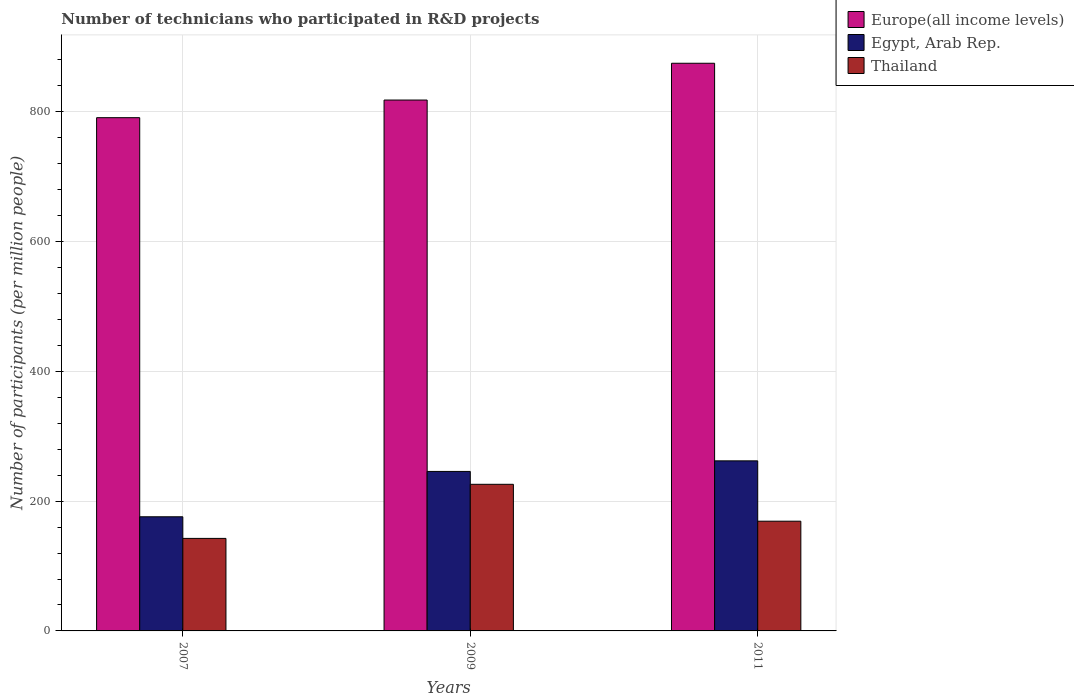Are the number of bars per tick equal to the number of legend labels?
Offer a terse response. Yes. Are the number of bars on each tick of the X-axis equal?
Your answer should be compact. Yes. What is the label of the 3rd group of bars from the left?
Give a very brief answer. 2011. What is the number of technicians who participated in R&D projects in Egypt, Arab Rep. in 2007?
Offer a very short reply. 175.89. Across all years, what is the maximum number of technicians who participated in R&D projects in Thailand?
Ensure brevity in your answer.  225.94. Across all years, what is the minimum number of technicians who participated in R&D projects in Europe(all income levels)?
Ensure brevity in your answer.  790.9. What is the total number of technicians who participated in R&D projects in Egypt, Arab Rep. in the graph?
Make the answer very short. 683.72. What is the difference between the number of technicians who participated in R&D projects in Europe(all income levels) in 2009 and that in 2011?
Provide a short and direct response. -56.67. What is the difference between the number of technicians who participated in R&D projects in Thailand in 2011 and the number of technicians who participated in R&D projects in Egypt, Arab Rep. in 2007?
Keep it short and to the point. -6.79. What is the average number of technicians who participated in R&D projects in Europe(all income levels) per year?
Offer a very short reply. 827.92. In the year 2007, what is the difference between the number of technicians who participated in R&D projects in Europe(all income levels) and number of technicians who participated in R&D projects in Egypt, Arab Rep.?
Give a very brief answer. 615.01. In how many years, is the number of technicians who participated in R&D projects in Egypt, Arab Rep. greater than 720?
Provide a succinct answer. 0. What is the ratio of the number of technicians who participated in R&D projects in Egypt, Arab Rep. in 2009 to that in 2011?
Provide a succinct answer. 0.94. Is the number of technicians who participated in R&D projects in Thailand in 2009 less than that in 2011?
Provide a short and direct response. No. What is the difference between the highest and the second highest number of technicians who participated in R&D projects in Egypt, Arab Rep.?
Your response must be concise. 16.3. What is the difference between the highest and the lowest number of technicians who participated in R&D projects in Egypt, Arab Rep.?
Provide a succinct answer. 86.18. What does the 2nd bar from the left in 2007 represents?
Your answer should be compact. Egypt, Arab Rep. What does the 1st bar from the right in 2009 represents?
Ensure brevity in your answer.  Thailand. Is it the case that in every year, the sum of the number of technicians who participated in R&D projects in Thailand and number of technicians who participated in R&D projects in Egypt, Arab Rep. is greater than the number of technicians who participated in R&D projects in Europe(all income levels)?
Ensure brevity in your answer.  No. How many bars are there?
Your response must be concise. 9. How many years are there in the graph?
Make the answer very short. 3. Are the values on the major ticks of Y-axis written in scientific E-notation?
Provide a short and direct response. No. Does the graph contain grids?
Provide a succinct answer. Yes. How many legend labels are there?
Make the answer very short. 3. What is the title of the graph?
Provide a succinct answer. Number of technicians who participated in R&D projects. Does "Gambia, The" appear as one of the legend labels in the graph?
Your answer should be compact. No. What is the label or title of the X-axis?
Your answer should be very brief. Years. What is the label or title of the Y-axis?
Your response must be concise. Number of participants (per million people). What is the Number of participants (per million people) of Europe(all income levels) in 2007?
Offer a very short reply. 790.9. What is the Number of participants (per million people) in Egypt, Arab Rep. in 2007?
Provide a short and direct response. 175.89. What is the Number of participants (per million people) of Thailand in 2007?
Provide a succinct answer. 142.58. What is the Number of participants (per million people) of Europe(all income levels) in 2009?
Provide a short and direct response. 818.09. What is the Number of participants (per million people) of Egypt, Arab Rep. in 2009?
Your answer should be compact. 245.77. What is the Number of participants (per million people) of Thailand in 2009?
Keep it short and to the point. 225.94. What is the Number of participants (per million people) of Europe(all income levels) in 2011?
Offer a terse response. 874.77. What is the Number of participants (per million people) in Egypt, Arab Rep. in 2011?
Give a very brief answer. 262.07. What is the Number of participants (per million people) of Thailand in 2011?
Your answer should be very brief. 169.1. Across all years, what is the maximum Number of participants (per million people) of Europe(all income levels)?
Provide a short and direct response. 874.77. Across all years, what is the maximum Number of participants (per million people) of Egypt, Arab Rep.?
Give a very brief answer. 262.07. Across all years, what is the maximum Number of participants (per million people) in Thailand?
Offer a terse response. 225.94. Across all years, what is the minimum Number of participants (per million people) of Europe(all income levels)?
Provide a succinct answer. 790.9. Across all years, what is the minimum Number of participants (per million people) of Egypt, Arab Rep.?
Provide a short and direct response. 175.89. Across all years, what is the minimum Number of participants (per million people) of Thailand?
Provide a short and direct response. 142.58. What is the total Number of participants (per million people) of Europe(all income levels) in the graph?
Your answer should be compact. 2483.76. What is the total Number of participants (per million people) in Egypt, Arab Rep. in the graph?
Keep it short and to the point. 683.72. What is the total Number of participants (per million people) of Thailand in the graph?
Provide a succinct answer. 537.62. What is the difference between the Number of participants (per million people) of Europe(all income levels) in 2007 and that in 2009?
Give a very brief answer. -27.19. What is the difference between the Number of participants (per million people) in Egypt, Arab Rep. in 2007 and that in 2009?
Keep it short and to the point. -69.88. What is the difference between the Number of participants (per million people) in Thailand in 2007 and that in 2009?
Keep it short and to the point. -83.36. What is the difference between the Number of participants (per million people) in Europe(all income levels) in 2007 and that in 2011?
Your response must be concise. -83.87. What is the difference between the Number of participants (per million people) in Egypt, Arab Rep. in 2007 and that in 2011?
Provide a succinct answer. -86.18. What is the difference between the Number of participants (per million people) in Thailand in 2007 and that in 2011?
Provide a short and direct response. -26.51. What is the difference between the Number of participants (per million people) of Europe(all income levels) in 2009 and that in 2011?
Provide a succinct answer. -56.67. What is the difference between the Number of participants (per million people) of Egypt, Arab Rep. in 2009 and that in 2011?
Offer a very short reply. -16.3. What is the difference between the Number of participants (per million people) in Thailand in 2009 and that in 2011?
Provide a succinct answer. 56.85. What is the difference between the Number of participants (per million people) of Europe(all income levels) in 2007 and the Number of participants (per million people) of Egypt, Arab Rep. in 2009?
Provide a succinct answer. 545.14. What is the difference between the Number of participants (per million people) in Europe(all income levels) in 2007 and the Number of participants (per million people) in Thailand in 2009?
Your response must be concise. 564.96. What is the difference between the Number of participants (per million people) of Egypt, Arab Rep. in 2007 and the Number of participants (per million people) of Thailand in 2009?
Keep it short and to the point. -50.05. What is the difference between the Number of participants (per million people) in Europe(all income levels) in 2007 and the Number of participants (per million people) in Egypt, Arab Rep. in 2011?
Offer a very short reply. 528.84. What is the difference between the Number of participants (per million people) of Europe(all income levels) in 2007 and the Number of participants (per million people) of Thailand in 2011?
Make the answer very short. 621.81. What is the difference between the Number of participants (per million people) of Egypt, Arab Rep. in 2007 and the Number of participants (per million people) of Thailand in 2011?
Provide a short and direct response. 6.79. What is the difference between the Number of participants (per million people) in Europe(all income levels) in 2009 and the Number of participants (per million people) in Egypt, Arab Rep. in 2011?
Ensure brevity in your answer.  556.03. What is the difference between the Number of participants (per million people) in Europe(all income levels) in 2009 and the Number of participants (per million people) in Thailand in 2011?
Your answer should be compact. 649. What is the difference between the Number of participants (per million people) in Egypt, Arab Rep. in 2009 and the Number of participants (per million people) in Thailand in 2011?
Offer a terse response. 76.67. What is the average Number of participants (per million people) in Europe(all income levels) per year?
Provide a succinct answer. 827.92. What is the average Number of participants (per million people) of Egypt, Arab Rep. per year?
Make the answer very short. 227.91. What is the average Number of participants (per million people) of Thailand per year?
Your response must be concise. 179.21. In the year 2007, what is the difference between the Number of participants (per million people) in Europe(all income levels) and Number of participants (per million people) in Egypt, Arab Rep.?
Keep it short and to the point. 615.01. In the year 2007, what is the difference between the Number of participants (per million people) of Europe(all income levels) and Number of participants (per million people) of Thailand?
Offer a very short reply. 648.32. In the year 2007, what is the difference between the Number of participants (per million people) in Egypt, Arab Rep. and Number of participants (per million people) in Thailand?
Your answer should be very brief. 33.31. In the year 2009, what is the difference between the Number of participants (per million people) of Europe(all income levels) and Number of participants (per million people) of Egypt, Arab Rep.?
Provide a succinct answer. 572.33. In the year 2009, what is the difference between the Number of participants (per million people) in Europe(all income levels) and Number of participants (per million people) in Thailand?
Your response must be concise. 592.15. In the year 2009, what is the difference between the Number of participants (per million people) in Egypt, Arab Rep. and Number of participants (per million people) in Thailand?
Your answer should be very brief. 19.82. In the year 2011, what is the difference between the Number of participants (per million people) of Europe(all income levels) and Number of participants (per million people) of Egypt, Arab Rep.?
Give a very brief answer. 612.7. In the year 2011, what is the difference between the Number of participants (per million people) in Europe(all income levels) and Number of participants (per million people) in Thailand?
Make the answer very short. 705.67. In the year 2011, what is the difference between the Number of participants (per million people) in Egypt, Arab Rep. and Number of participants (per million people) in Thailand?
Give a very brief answer. 92.97. What is the ratio of the Number of participants (per million people) of Europe(all income levels) in 2007 to that in 2009?
Keep it short and to the point. 0.97. What is the ratio of the Number of participants (per million people) of Egypt, Arab Rep. in 2007 to that in 2009?
Your answer should be compact. 0.72. What is the ratio of the Number of participants (per million people) in Thailand in 2007 to that in 2009?
Offer a terse response. 0.63. What is the ratio of the Number of participants (per million people) in Europe(all income levels) in 2007 to that in 2011?
Make the answer very short. 0.9. What is the ratio of the Number of participants (per million people) in Egypt, Arab Rep. in 2007 to that in 2011?
Provide a short and direct response. 0.67. What is the ratio of the Number of participants (per million people) in Thailand in 2007 to that in 2011?
Keep it short and to the point. 0.84. What is the ratio of the Number of participants (per million people) of Europe(all income levels) in 2009 to that in 2011?
Offer a very short reply. 0.94. What is the ratio of the Number of participants (per million people) of Egypt, Arab Rep. in 2009 to that in 2011?
Your answer should be compact. 0.94. What is the ratio of the Number of participants (per million people) of Thailand in 2009 to that in 2011?
Your answer should be compact. 1.34. What is the difference between the highest and the second highest Number of participants (per million people) of Europe(all income levels)?
Make the answer very short. 56.67. What is the difference between the highest and the second highest Number of participants (per million people) of Egypt, Arab Rep.?
Ensure brevity in your answer.  16.3. What is the difference between the highest and the second highest Number of participants (per million people) of Thailand?
Offer a very short reply. 56.85. What is the difference between the highest and the lowest Number of participants (per million people) in Europe(all income levels)?
Give a very brief answer. 83.87. What is the difference between the highest and the lowest Number of participants (per million people) of Egypt, Arab Rep.?
Give a very brief answer. 86.18. What is the difference between the highest and the lowest Number of participants (per million people) in Thailand?
Offer a very short reply. 83.36. 